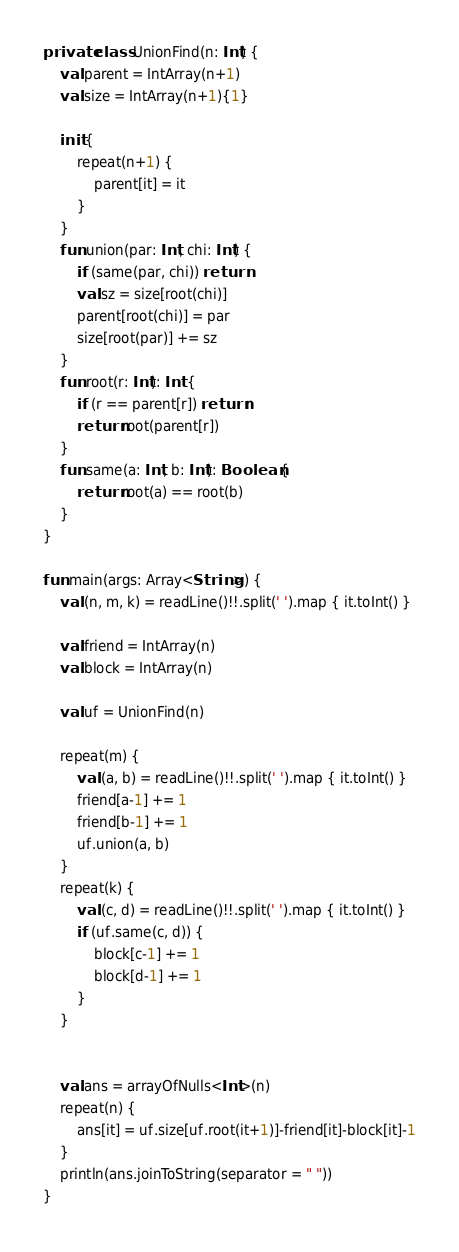Convert code to text. <code><loc_0><loc_0><loc_500><loc_500><_Kotlin_>private class UnionFind(n: Int) {
    val parent = IntArray(n+1)
    val size = IntArray(n+1){1}

    init {
        repeat(n+1) {
            parent[it] = it
        }
    }
    fun union(par: Int, chi: Int) {
        if (same(par, chi)) return
        val sz = size[root(chi)]
        parent[root(chi)] = par
        size[root(par)] += sz
    }
    fun root(r: Int): Int {
        if (r == parent[r]) return r
        return root(parent[r])
    }
    fun same(a: Int, b: Int): Boolean {
        return root(a) == root(b)
    }
}

fun main(args: Array<String>) {
    val (n, m, k) = readLine()!!.split(' ').map { it.toInt() }

    val friend = IntArray(n)
    val block = IntArray(n)

    val uf = UnionFind(n)

    repeat(m) {
        val (a, b) = readLine()!!.split(' ').map { it.toInt() }
        friend[a-1] += 1
        friend[b-1] += 1
        uf.union(a, b)
    }
    repeat(k) {
        val (c, d) = readLine()!!.split(' ').map { it.toInt() }
        if (uf.same(c, d)) {
            block[c-1] += 1
            block[d-1] += 1
        }
    }


    val ans = arrayOfNulls<Int>(n)
    repeat(n) {
        ans[it] = uf.size[uf.root(it+1)]-friend[it]-block[it]-1
    }
    println(ans.joinToString(separator = " "))
}
</code> 